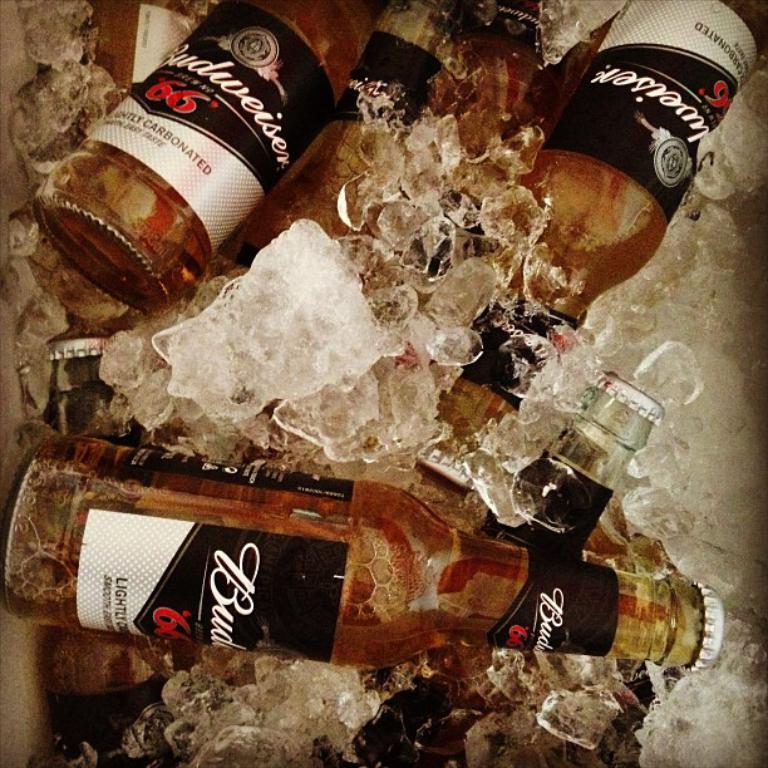What objects are present in the image? There are bottles in the image. How are the bottles arranged or positioned? The bottles are surrounded by ice cubes. Can you hear the bear sneezing in the image? There is no bear or sneezing sound present in the image. 